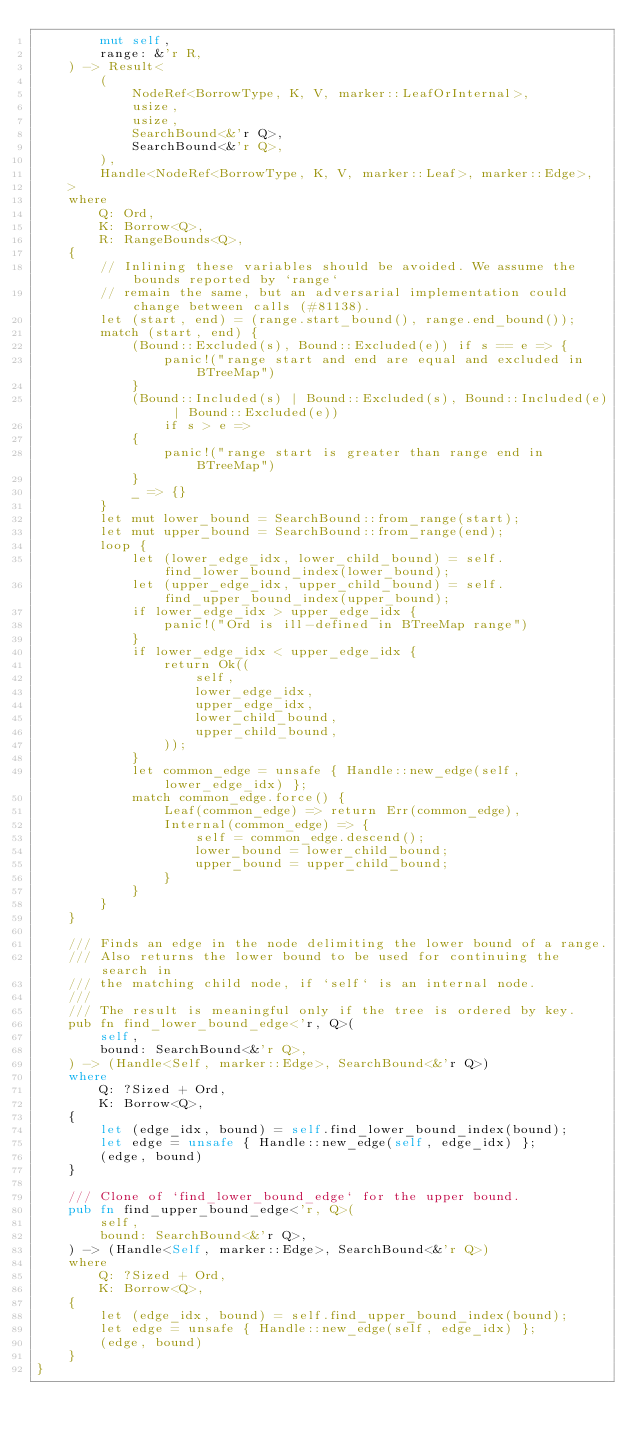Convert code to text. <code><loc_0><loc_0><loc_500><loc_500><_Rust_>        mut self,
        range: &'r R,
    ) -> Result<
        (
            NodeRef<BorrowType, K, V, marker::LeafOrInternal>,
            usize,
            usize,
            SearchBound<&'r Q>,
            SearchBound<&'r Q>,
        ),
        Handle<NodeRef<BorrowType, K, V, marker::Leaf>, marker::Edge>,
    >
    where
        Q: Ord,
        K: Borrow<Q>,
        R: RangeBounds<Q>,
    {
        // Inlining these variables should be avoided. We assume the bounds reported by `range`
        // remain the same, but an adversarial implementation could change between calls (#81138).
        let (start, end) = (range.start_bound(), range.end_bound());
        match (start, end) {
            (Bound::Excluded(s), Bound::Excluded(e)) if s == e => {
                panic!("range start and end are equal and excluded in BTreeMap")
            }
            (Bound::Included(s) | Bound::Excluded(s), Bound::Included(e) | Bound::Excluded(e))
                if s > e =>
            {
                panic!("range start is greater than range end in BTreeMap")
            }
            _ => {}
        }
        let mut lower_bound = SearchBound::from_range(start);
        let mut upper_bound = SearchBound::from_range(end);
        loop {
            let (lower_edge_idx, lower_child_bound) = self.find_lower_bound_index(lower_bound);
            let (upper_edge_idx, upper_child_bound) = self.find_upper_bound_index(upper_bound);
            if lower_edge_idx > upper_edge_idx {
                panic!("Ord is ill-defined in BTreeMap range")
            }
            if lower_edge_idx < upper_edge_idx {
                return Ok((
                    self,
                    lower_edge_idx,
                    upper_edge_idx,
                    lower_child_bound,
                    upper_child_bound,
                ));
            }
            let common_edge = unsafe { Handle::new_edge(self, lower_edge_idx) };
            match common_edge.force() {
                Leaf(common_edge) => return Err(common_edge),
                Internal(common_edge) => {
                    self = common_edge.descend();
                    lower_bound = lower_child_bound;
                    upper_bound = upper_child_bound;
                }
            }
        }
    }

    /// Finds an edge in the node delimiting the lower bound of a range.
    /// Also returns the lower bound to be used for continuing the search in
    /// the matching child node, if `self` is an internal node.
    ///
    /// The result is meaningful only if the tree is ordered by key.
    pub fn find_lower_bound_edge<'r, Q>(
        self,
        bound: SearchBound<&'r Q>,
    ) -> (Handle<Self, marker::Edge>, SearchBound<&'r Q>)
    where
        Q: ?Sized + Ord,
        K: Borrow<Q>,
    {
        let (edge_idx, bound) = self.find_lower_bound_index(bound);
        let edge = unsafe { Handle::new_edge(self, edge_idx) };
        (edge, bound)
    }

    /// Clone of `find_lower_bound_edge` for the upper bound.
    pub fn find_upper_bound_edge<'r, Q>(
        self,
        bound: SearchBound<&'r Q>,
    ) -> (Handle<Self, marker::Edge>, SearchBound<&'r Q>)
    where
        Q: ?Sized + Ord,
        K: Borrow<Q>,
    {
        let (edge_idx, bound) = self.find_upper_bound_index(bound);
        let edge = unsafe { Handle::new_edge(self, edge_idx) };
        (edge, bound)
    }
}
</code> 